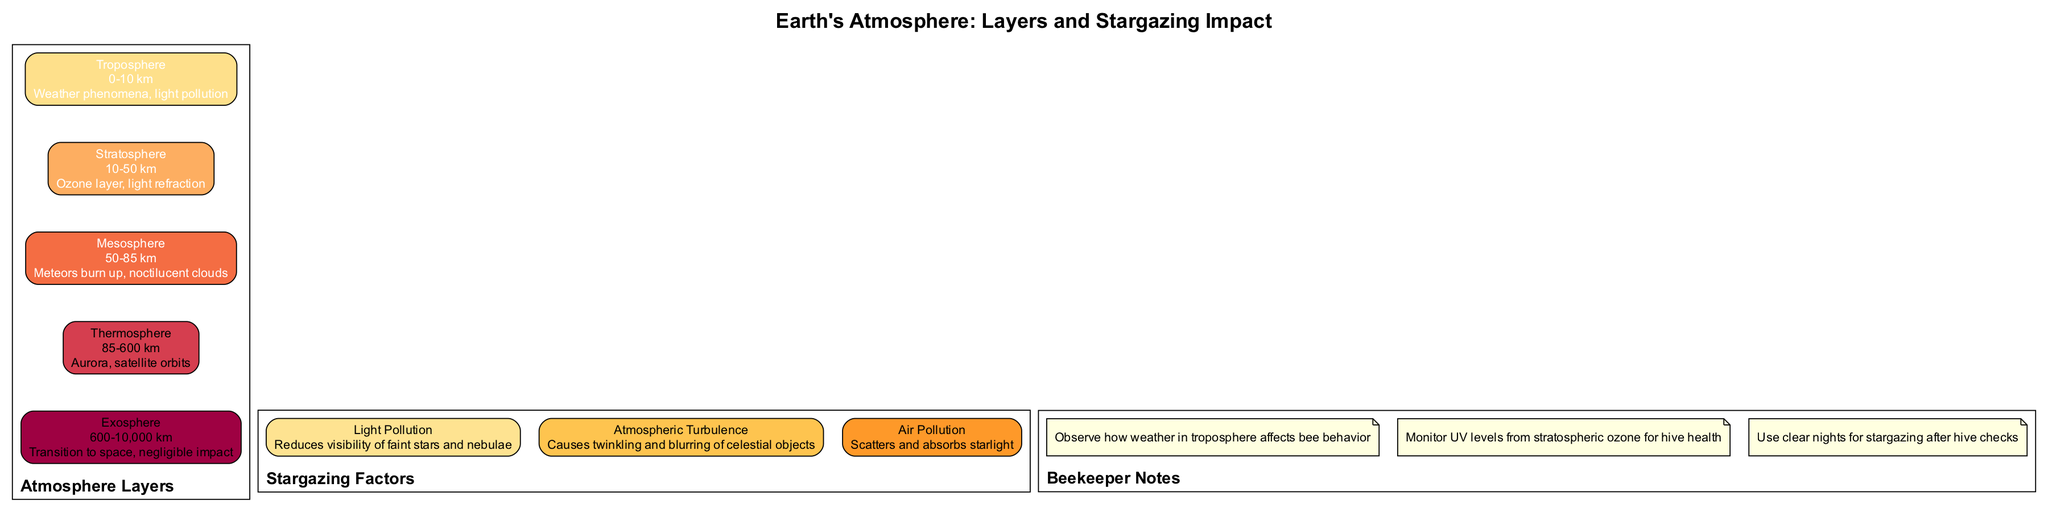What is the height range of the Troposphere? The diagram lists the height range of the Troposphere as "0-10 km" directly under the Troposphere label.
Answer: 0-10 km What atmospheric layer follows the Stratosphere? The layers are arranged in a descending order, and the layer that immediately follows the Stratosphere is the Troposphere.
Answer: Troposphere How many stargazing factors are listed in the diagram? By counting the nodes under the Stargazing Factors section, there are three factors provided.
Answer: 3 What effect does the Mesosphere have? The effect of the Mesosphere is described as "Meteors burn up, noctilucent clouds" as listed in the diagram.
Answer: Meteors burn up, noctilucent clouds Which layer is indicated to have a significant impact on satellite orbits? The diagram specifies that the Thermosphere has the effect of "Aurora, satellite orbits," thus indicating its importance for satellites.
Answer: Thermosphere What impact does light pollution have on stargazing? The diagram notes that light pollution "Reduces visibility of faint stars and nebulae," which directly indicates its impact on stargazing.
Answer: Reduces visibility of faint stars and nebulae Which layer contains the ozone layer critical for UV protection? According to the diagram, the Stratosphere is identified to contain the ozone layer, indicating its importance in UV protection.
Answer: Stratosphere What is mentioned about Noctilucent clouds in the context of the atmosphere? The diagram states that "Noctilucent clouds" are an effect of the Mesosphere, showing the atmospheric phenomenon occurring in that layer.
Answer: Noctilucent clouds How does the Troposphere affect bee behavior according to the beekeeper notes? The beekeeper notes assert that one should "Observe how weather in troposphere affects bee behavior," which highlights the importance of weather in this layer for bees.
Answer: Observe how weather in troposphere affects bee behavior 